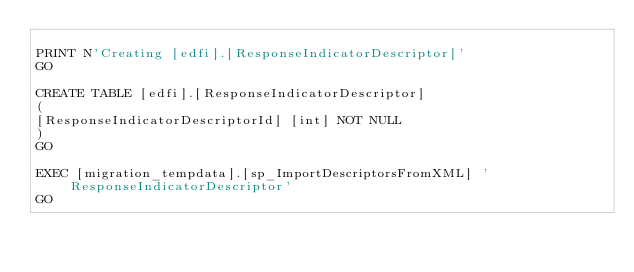Convert code to text. <code><loc_0><loc_0><loc_500><loc_500><_SQL_>
PRINT N'Creating [edfi].[ResponseIndicatorDescriptor]'
GO

CREATE TABLE [edfi].[ResponseIndicatorDescriptor]
(
[ResponseIndicatorDescriptorId] [int] NOT NULL
)
GO

EXEC [migration_tempdata].[sp_ImportDescriptorsFromXML] 'ResponseIndicatorDescriptor'
GO

</code> 